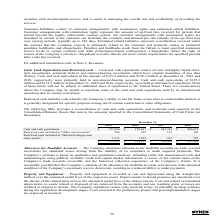According to Sykes Enterprises Incorporated's financial document, What was the amount of cash and cash equivalents in 2019? According to the financial document, $127.2 million. The relevant text states: "0 days. Cash and cash equivalents in the amount of $127.2 million and $128.7 million at December 31, 2019 and 2018, respectively, were primarily held in non-interest-..." Also, What does restricted cash include? includes cash whereby the Company’s ability to use the funds at any time is contractually limited or is generally designated for specific purposes arising out of certain contractual or other obligations.. The document states: "Restricted cash includes cash whereby the Company’s ability to use the funds at any time is contractually limited or is generally designated for speci..." Also, In which years was Cash and cash equivalents calculated? The document contains multiple relevant values: 2019, 2018, 2017, 2016. From the document: "2019 2018 2017 2016 2019 2018 2017 2016 2019 2018 2017 2016 2019 2018 2017 2016..." Additionally, In which year was Restricted cash included in "Other current assets" the lowest? According to the financial document, 2018. The relevant text states: "2019 2018 2017 2016..." Also, can you calculate: What was the change in Restricted cash included in "Deferred charges and other assets" in 2017 from 2016? Based on the calculation: 917-759, the result is 158 (in thousands). This is based on the information: "n "Deferred charges and other assets" 1,371 1,385 917 759 eferred charges and other assets" 1,371 1,385 917 759..." The key data points involved are: 759, 917. Also, can you calculate: What was the percentage change in Restricted cash included in "Deferred charges and other assets" in 2017 from 2016? To answer this question, I need to perform calculations using the financial data. The calculation is: (917-759)/759, which equals 20.82 (percentage). This is based on the information: "n "Deferred charges and other assets" 1,371 1,385 917 759 eferred charges and other assets" 1,371 1,385 917 759..." The key data points involved are: 759, 917. 